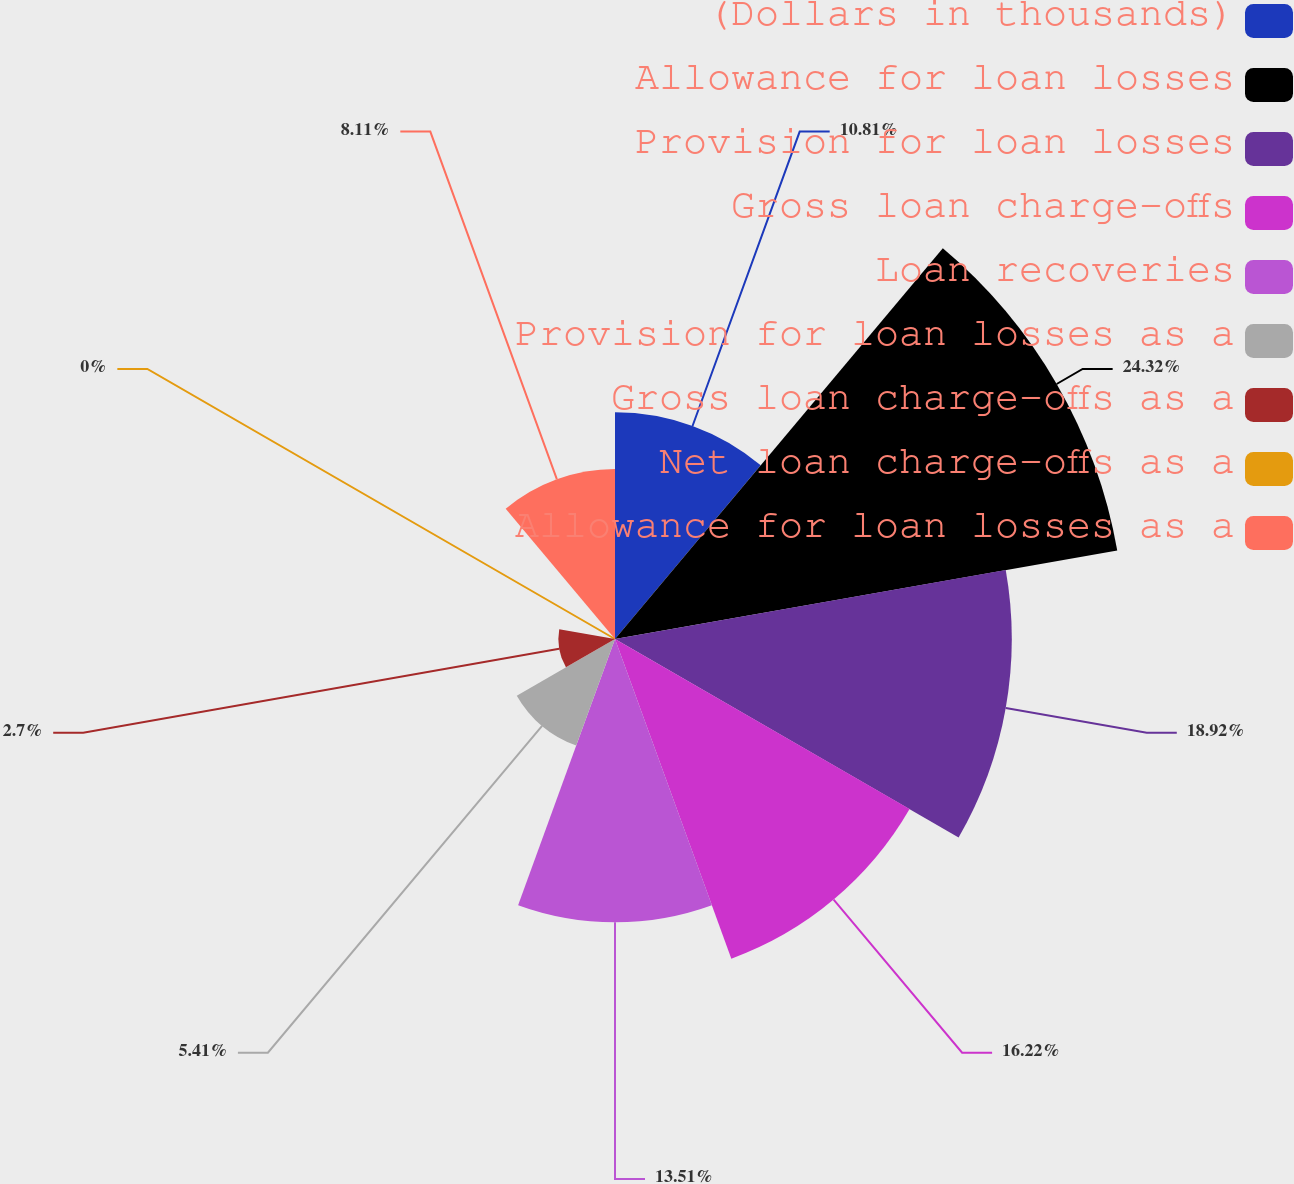Convert chart to OTSL. <chart><loc_0><loc_0><loc_500><loc_500><pie_chart><fcel>(Dollars in thousands)<fcel>Allowance for loan losses<fcel>Provision for loan losses<fcel>Gross loan charge-offs<fcel>Loan recoveries<fcel>Provision for loan losses as a<fcel>Gross loan charge-offs as a<fcel>Net loan charge-offs as a<fcel>Allowance for loan losses as a<nl><fcel>10.81%<fcel>24.32%<fcel>18.92%<fcel>16.22%<fcel>13.51%<fcel>5.41%<fcel>2.7%<fcel>0.0%<fcel>8.11%<nl></chart> 